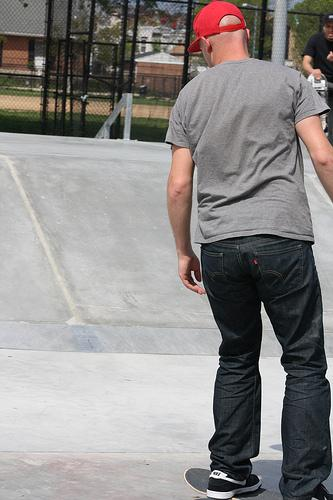Examine the image for any signs or symbols on the featured person's clothing. There is a red tag on the skateboarder's Levi jeans, and a company logo on his black and white sneakers. Describe the scene near the steps in the image. Near the steps, there is a metal railing, a handrail for support, and a cement slope leading towards the skate park. What is the overall atmosphere of the image in terms of action and location? The atmosphere is energetic, with the main focus being a young man skateboarding at a skate park, surrounded by various park features and other people. What activity is the main character in the image participating in? The main character is a man skateboarding at a skate park. Please specify the type of sneakers the main subject is wearing. The man is wearing black and white sneakers on his feet, possibly Nike brand. What is the main subject in the picture wearing on his head? The man is wearing a red hat on his head. What type of pants is the person skateboarding wearing? The skateboarder is wearing blue jeans, specifically Levi's with a red tag on the back pocket. Analyze the image and describe the area where the skateboarder is performing. The skateboarder is at a skate park with ramps, a metal handrail, and a black chainlink fence, with houses in the background. Is there anyone else in the image apart from the main subject? If so, describe their appearance and what they are doing. Yes, there is another man in the background wearing a black shirt, possibly watching the skateboarder or holding a skateboard. Identify and describe the fence in the background of the picture. There is a black chainlink fence located behind the skateboarder at the skate park. List the types of interactions between objects or people. Man skateboarding, man observing the skateboarder. What item is attached to the man's pants? A red tag What is the man wearing on his head? A red hat Is there a green hat on the man's head? The man is wearing a red hat, not a green one. Is the man skateboarding on a grassy field? The image depicts a man skateboarding, but the location is a skate park with concrete ramps rather than a grassy field. How does the quality of the image appear? The image quality appears clear and sharp. What is the man doing with the skateboard? Skateboarding List any attributes of the man's pants. Levi blue jeans, red tag Is the man in the background wearing a black shirt? Yes Find and list any visible handrails in the image. Metal handrail (X:71 Y:87 Width:70 Height:70), handrail for steps (X:97 Y:87 Width:45 Height:45) Is the man wearing sandals instead of sneakers? The man is wearing black and white sneakers, not sandals. Describe the type of environment surrounding the man. Skateboard park with houses in the background and a black chainlink fence. In the picture, where is the company logo located? On a sneaker (X:204 Y:476 Width:18 Height:18) Identify the emotions displayed in the image. Neutral emotions Describe the attributes of the man's shoes. Black and white, company logo, tennis shoes Which of the following is not in the picture: a red hat, a black shirt, or a blue bird? A blue bird Is there a man in the image who is not skateboarding? Yes, there is a man watching the skateboarder. List any text or logos that appear in the image. Company logo on a sneaker What is the man wearing on his feet? Black and white sneakers Determine if there are any anomalies in the picture. No visible anomalies detected. Can you spot the yellow tag on his pants? The image contains a red tag on the man's pants, not a yellow one. Refer to the man in a gray t-shirt and locate him in the image. X:174 Y:9 Width:112 Height:112 Is there a dog jumping over the black mesh fence at the skate park? The image has a black mesh fence, but there is no dog jumping over it. Explain the primary activity the man is engaged in. The man is skateboarding. Are there birds sitting on the metal railing? The image contains a metal railing, but there are no birds on it. Determine the type of environment in which the man with the skateboard is located. Ramp at skateboard park 